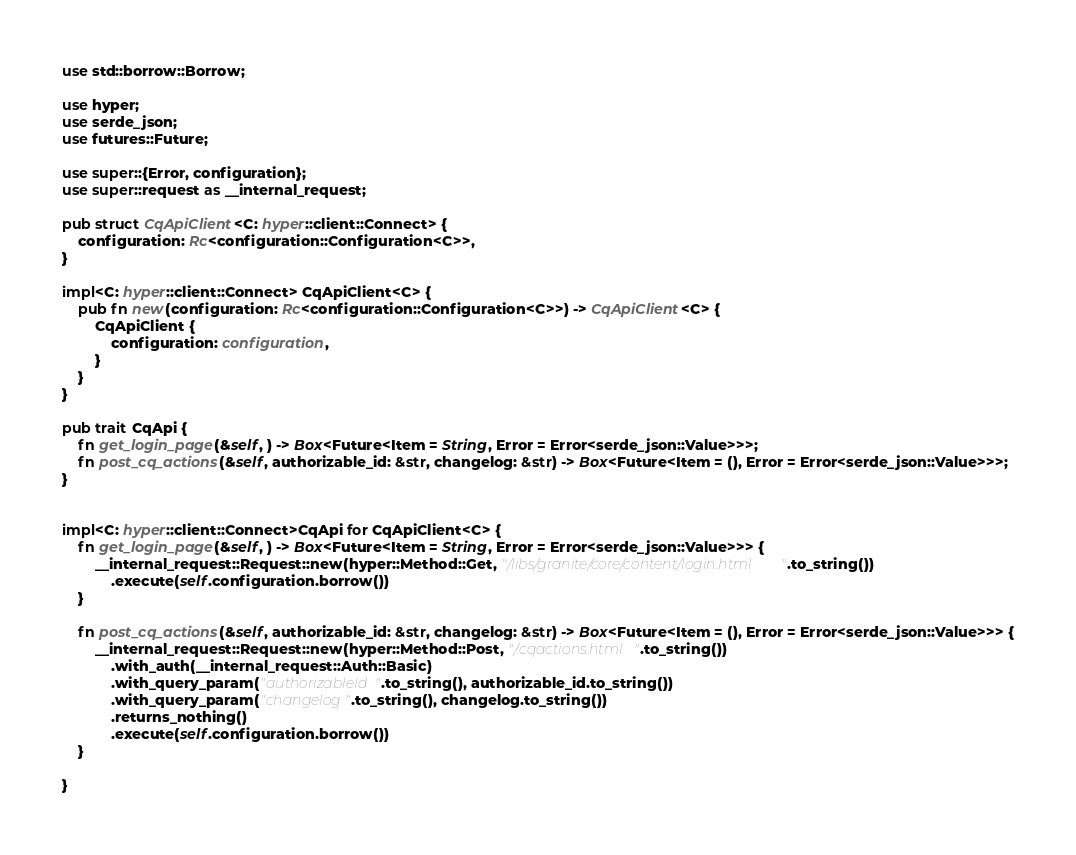<code> <loc_0><loc_0><loc_500><loc_500><_Rust_>use std::borrow::Borrow;

use hyper;
use serde_json;
use futures::Future;

use super::{Error, configuration};
use super::request as __internal_request;

pub struct CqApiClient<C: hyper::client::Connect> {
    configuration: Rc<configuration::Configuration<C>>,
}

impl<C: hyper::client::Connect> CqApiClient<C> {
    pub fn new(configuration: Rc<configuration::Configuration<C>>) -> CqApiClient<C> {
        CqApiClient {
            configuration: configuration,
        }
    }
}

pub trait CqApi {
    fn get_login_page(&self, ) -> Box<Future<Item = String, Error = Error<serde_json::Value>>>;
    fn post_cq_actions(&self, authorizable_id: &str, changelog: &str) -> Box<Future<Item = (), Error = Error<serde_json::Value>>>;
}


impl<C: hyper::client::Connect>CqApi for CqApiClient<C> {
    fn get_login_page(&self, ) -> Box<Future<Item = String, Error = Error<serde_json::Value>>> {
        __internal_request::Request::new(hyper::Method::Get, "/libs/granite/core/content/login.html".to_string())
            .execute(self.configuration.borrow())
    }

    fn post_cq_actions(&self, authorizable_id: &str, changelog: &str) -> Box<Future<Item = (), Error = Error<serde_json::Value>>> {
        __internal_request::Request::new(hyper::Method::Post, "/.cqactions.html".to_string())
            .with_auth(__internal_request::Auth::Basic)
            .with_query_param("authorizableId".to_string(), authorizable_id.to_string())
            .with_query_param("changelog".to_string(), changelog.to_string())
            .returns_nothing()
            .execute(self.configuration.borrow())
    }

}
</code> 